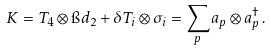<formula> <loc_0><loc_0><loc_500><loc_500>K = T _ { 4 } \otimes \i d _ { 2 } + \delta T _ { i } \otimes \sigma _ { i } = \sum _ { p } a _ { p } \otimes a _ { p } ^ { \dagger } \, .</formula> 